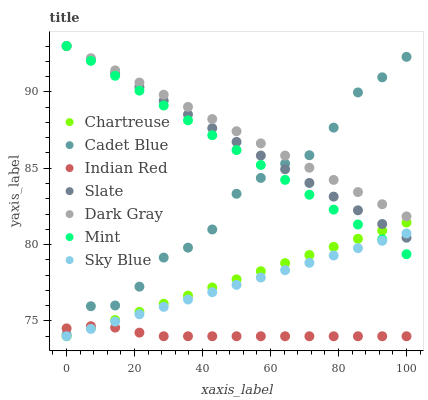Does Indian Red have the minimum area under the curve?
Answer yes or no. Yes. Does Dark Gray have the maximum area under the curve?
Answer yes or no. Yes. Does Slate have the minimum area under the curve?
Answer yes or no. No. Does Slate have the maximum area under the curve?
Answer yes or no. No. Is Mint the smoothest?
Answer yes or no. Yes. Is Cadet Blue the roughest?
Answer yes or no. Yes. Is Slate the smoothest?
Answer yes or no. No. Is Slate the roughest?
Answer yes or no. No. Does Chartreuse have the lowest value?
Answer yes or no. Yes. Does Slate have the lowest value?
Answer yes or no. No. Does Mint have the highest value?
Answer yes or no. Yes. Does Chartreuse have the highest value?
Answer yes or no. No. Is Indian Red less than Slate?
Answer yes or no. Yes. Is Slate greater than Indian Red?
Answer yes or no. Yes. Does Slate intersect Sky Blue?
Answer yes or no. Yes. Is Slate less than Sky Blue?
Answer yes or no. No. Is Slate greater than Sky Blue?
Answer yes or no. No. Does Indian Red intersect Slate?
Answer yes or no. No. 